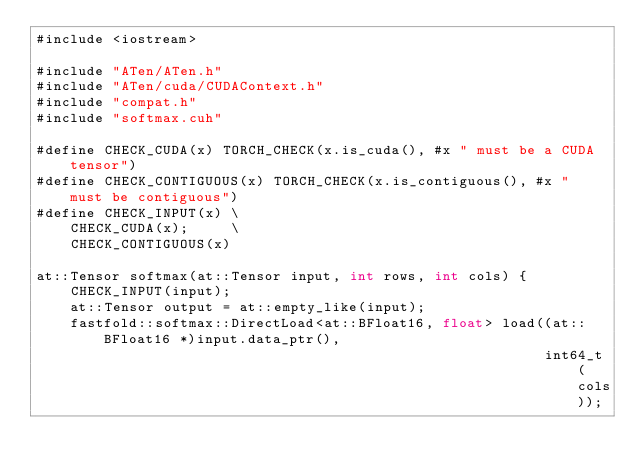<code> <loc_0><loc_0><loc_500><loc_500><_Cuda_>#include <iostream>

#include "ATen/ATen.h"
#include "ATen/cuda/CUDAContext.h"
#include "compat.h"
#include "softmax.cuh"

#define CHECK_CUDA(x) TORCH_CHECK(x.is_cuda(), #x " must be a CUDA tensor")
#define CHECK_CONTIGUOUS(x) TORCH_CHECK(x.is_contiguous(), #x " must be contiguous")
#define CHECK_INPUT(x) \
    CHECK_CUDA(x);     \
    CHECK_CONTIGUOUS(x)

at::Tensor softmax(at::Tensor input, int rows, int cols) {
    CHECK_INPUT(input);
    at::Tensor output = at::empty_like(input);
    fastfold::softmax::DirectLoad<at::BFloat16, float> load((at::BFloat16 *)input.data_ptr(),
                                                            int64_t(cols));</code> 